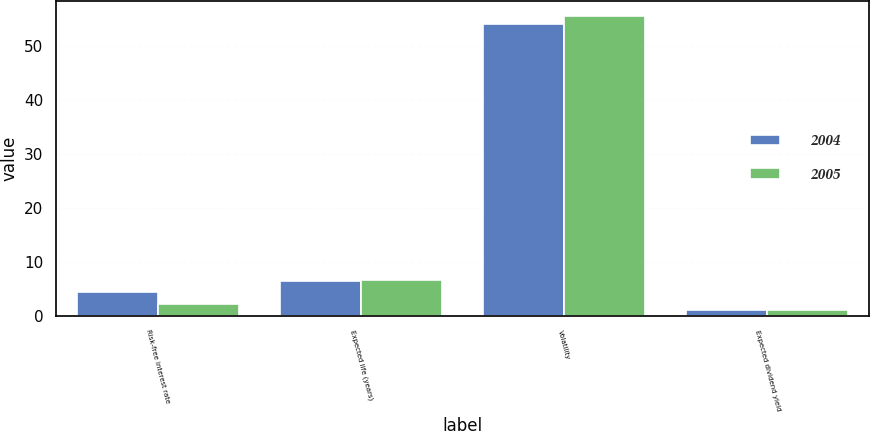<chart> <loc_0><loc_0><loc_500><loc_500><stacked_bar_chart><ecel><fcel>Risk-free interest rate<fcel>Expected life (years)<fcel>Volatility<fcel>Expected dividend yield<nl><fcel>2004<fcel>4.33<fcel>6.38<fcel>54.1<fcel>1.06<nl><fcel>2005<fcel>2.19<fcel>6.58<fcel>55.6<fcel>1.08<nl></chart> 